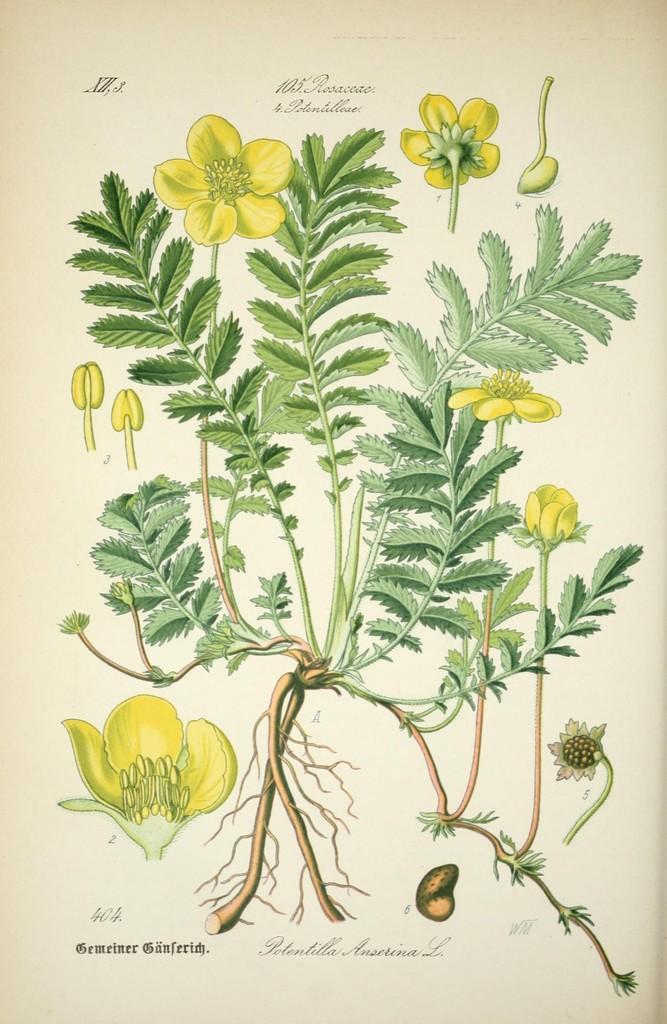Describe this image in one or two sentences. In this image we can see a picture of a plant with group of flowers, roots and some text on it. 